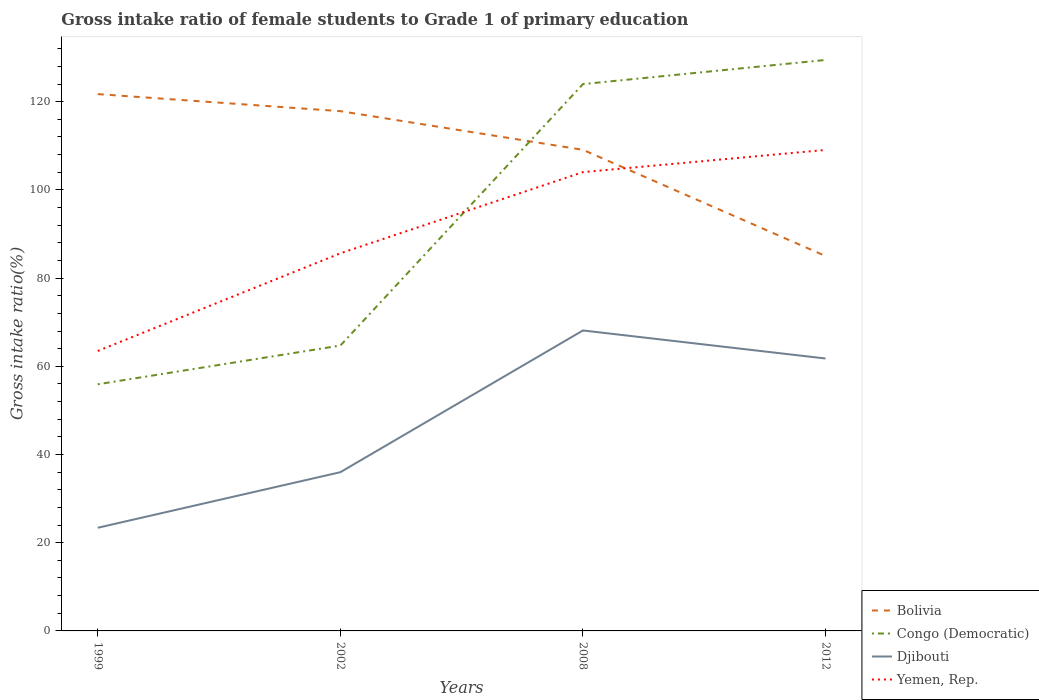How many different coloured lines are there?
Keep it short and to the point. 4. Does the line corresponding to Yemen, Rep. intersect with the line corresponding to Bolivia?
Your answer should be very brief. Yes. Is the number of lines equal to the number of legend labels?
Offer a terse response. Yes. Across all years, what is the maximum gross intake ratio in Djibouti?
Ensure brevity in your answer.  23.39. What is the total gross intake ratio in Yemen, Rep. in the graph?
Ensure brevity in your answer.  -5.03. What is the difference between the highest and the second highest gross intake ratio in Bolivia?
Give a very brief answer. 36.71. How many years are there in the graph?
Give a very brief answer. 4. What is the difference between two consecutive major ticks on the Y-axis?
Keep it short and to the point. 20. Does the graph contain grids?
Provide a short and direct response. No. Where does the legend appear in the graph?
Your response must be concise. Bottom right. How many legend labels are there?
Your answer should be very brief. 4. What is the title of the graph?
Your response must be concise. Gross intake ratio of female students to Grade 1 of primary education. Does "Greece" appear as one of the legend labels in the graph?
Provide a succinct answer. No. What is the label or title of the Y-axis?
Your answer should be very brief. Gross intake ratio(%). What is the Gross intake ratio(%) of Bolivia in 1999?
Provide a succinct answer. 121.71. What is the Gross intake ratio(%) in Congo (Democratic) in 1999?
Provide a succinct answer. 55.92. What is the Gross intake ratio(%) in Djibouti in 1999?
Your response must be concise. 23.39. What is the Gross intake ratio(%) in Yemen, Rep. in 1999?
Provide a short and direct response. 63.48. What is the Gross intake ratio(%) of Bolivia in 2002?
Your answer should be very brief. 117.84. What is the Gross intake ratio(%) in Congo (Democratic) in 2002?
Keep it short and to the point. 64.7. What is the Gross intake ratio(%) of Djibouti in 2002?
Offer a terse response. 35.99. What is the Gross intake ratio(%) of Yemen, Rep. in 2002?
Your response must be concise. 85.62. What is the Gross intake ratio(%) in Bolivia in 2008?
Offer a very short reply. 109.08. What is the Gross intake ratio(%) of Congo (Democratic) in 2008?
Offer a very short reply. 123.98. What is the Gross intake ratio(%) in Djibouti in 2008?
Offer a very short reply. 68.12. What is the Gross intake ratio(%) in Yemen, Rep. in 2008?
Make the answer very short. 104.02. What is the Gross intake ratio(%) of Bolivia in 2012?
Make the answer very short. 85. What is the Gross intake ratio(%) of Congo (Democratic) in 2012?
Give a very brief answer. 129.45. What is the Gross intake ratio(%) of Djibouti in 2012?
Your response must be concise. 61.76. What is the Gross intake ratio(%) of Yemen, Rep. in 2012?
Ensure brevity in your answer.  109.05. Across all years, what is the maximum Gross intake ratio(%) of Bolivia?
Your answer should be very brief. 121.71. Across all years, what is the maximum Gross intake ratio(%) in Congo (Democratic)?
Your answer should be very brief. 129.45. Across all years, what is the maximum Gross intake ratio(%) of Djibouti?
Keep it short and to the point. 68.12. Across all years, what is the maximum Gross intake ratio(%) of Yemen, Rep.?
Offer a very short reply. 109.05. Across all years, what is the minimum Gross intake ratio(%) of Bolivia?
Make the answer very short. 85. Across all years, what is the minimum Gross intake ratio(%) of Congo (Democratic)?
Your answer should be compact. 55.92. Across all years, what is the minimum Gross intake ratio(%) in Djibouti?
Give a very brief answer. 23.39. Across all years, what is the minimum Gross intake ratio(%) in Yemen, Rep.?
Make the answer very short. 63.48. What is the total Gross intake ratio(%) of Bolivia in the graph?
Keep it short and to the point. 433.64. What is the total Gross intake ratio(%) in Congo (Democratic) in the graph?
Provide a succinct answer. 374.06. What is the total Gross intake ratio(%) of Djibouti in the graph?
Make the answer very short. 189.27. What is the total Gross intake ratio(%) of Yemen, Rep. in the graph?
Your answer should be compact. 362.18. What is the difference between the Gross intake ratio(%) of Bolivia in 1999 and that in 2002?
Make the answer very short. 3.87. What is the difference between the Gross intake ratio(%) in Congo (Democratic) in 1999 and that in 2002?
Your answer should be compact. -8.78. What is the difference between the Gross intake ratio(%) in Djibouti in 1999 and that in 2002?
Offer a terse response. -12.6. What is the difference between the Gross intake ratio(%) in Yemen, Rep. in 1999 and that in 2002?
Make the answer very short. -22.14. What is the difference between the Gross intake ratio(%) in Bolivia in 1999 and that in 2008?
Give a very brief answer. 12.63. What is the difference between the Gross intake ratio(%) of Congo (Democratic) in 1999 and that in 2008?
Offer a terse response. -68.06. What is the difference between the Gross intake ratio(%) of Djibouti in 1999 and that in 2008?
Your response must be concise. -44.73. What is the difference between the Gross intake ratio(%) of Yemen, Rep. in 1999 and that in 2008?
Provide a succinct answer. -40.54. What is the difference between the Gross intake ratio(%) in Bolivia in 1999 and that in 2012?
Your answer should be compact. 36.71. What is the difference between the Gross intake ratio(%) in Congo (Democratic) in 1999 and that in 2012?
Your response must be concise. -73.53. What is the difference between the Gross intake ratio(%) of Djibouti in 1999 and that in 2012?
Provide a short and direct response. -38.37. What is the difference between the Gross intake ratio(%) in Yemen, Rep. in 1999 and that in 2012?
Your response must be concise. -45.57. What is the difference between the Gross intake ratio(%) of Bolivia in 2002 and that in 2008?
Provide a short and direct response. 8.76. What is the difference between the Gross intake ratio(%) of Congo (Democratic) in 2002 and that in 2008?
Offer a very short reply. -59.28. What is the difference between the Gross intake ratio(%) in Djibouti in 2002 and that in 2008?
Provide a short and direct response. -32.13. What is the difference between the Gross intake ratio(%) of Yemen, Rep. in 2002 and that in 2008?
Keep it short and to the point. -18.4. What is the difference between the Gross intake ratio(%) in Bolivia in 2002 and that in 2012?
Your answer should be very brief. 32.84. What is the difference between the Gross intake ratio(%) in Congo (Democratic) in 2002 and that in 2012?
Give a very brief answer. -64.75. What is the difference between the Gross intake ratio(%) of Djibouti in 2002 and that in 2012?
Ensure brevity in your answer.  -25.77. What is the difference between the Gross intake ratio(%) of Yemen, Rep. in 2002 and that in 2012?
Provide a short and direct response. -23.44. What is the difference between the Gross intake ratio(%) in Bolivia in 2008 and that in 2012?
Provide a succinct answer. 24.08. What is the difference between the Gross intake ratio(%) in Congo (Democratic) in 2008 and that in 2012?
Your response must be concise. -5.47. What is the difference between the Gross intake ratio(%) of Djibouti in 2008 and that in 2012?
Provide a short and direct response. 6.36. What is the difference between the Gross intake ratio(%) in Yemen, Rep. in 2008 and that in 2012?
Make the answer very short. -5.03. What is the difference between the Gross intake ratio(%) in Bolivia in 1999 and the Gross intake ratio(%) in Congo (Democratic) in 2002?
Your answer should be very brief. 57.01. What is the difference between the Gross intake ratio(%) of Bolivia in 1999 and the Gross intake ratio(%) of Djibouti in 2002?
Your response must be concise. 85.72. What is the difference between the Gross intake ratio(%) of Bolivia in 1999 and the Gross intake ratio(%) of Yemen, Rep. in 2002?
Your answer should be compact. 36.09. What is the difference between the Gross intake ratio(%) in Congo (Democratic) in 1999 and the Gross intake ratio(%) in Djibouti in 2002?
Your response must be concise. 19.93. What is the difference between the Gross intake ratio(%) of Congo (Democratic) in 1999 and the Gross intake ratio(%) of Yemen, Rep. in 2002?
Give a very brief answer. -29.7. What is the difference between the Gross intake ratio(%) in Djibouti in 1999 and the Gross intake ratio(%) in Yemen, Rep. in 2002?
Your answer should be compact. -62.23. What is the difference between the Gross intake ratio(%) of Bolivia in 1999 and the Gross intake ratio(%) of Congo (Democratic) in 2008?
Your answer should be compact. -2.27. What is the difference between the Gross intake ratio(%) in Bolivia in 1999 and the Gross intake ratio(%) in Djibouti in 2008?
Keep it short and to the point. 53.59. What is the difference between the Gross intake ratio(%) in Bolivia in 1999 and the Gross intake ratio(%) in Yemen, Rep. in 2008?
Keep it short and to the point. 17.69. What is the difference between the Gross intake ratio(%) in Congo (Democratic) in 1999 and the Gross intake ratio(%) in Djibouti in 2008?
Offer a very short reply. -12.2. What is the difference between the Gross intake ratio(%) in Congo (Democratic) in 1999 and the Gross intake ratio(%) in Yemen, Rep. in 2008?
Ensure brevity in your answer.  -48.1. What is the difference between the Gross intake ratio(%) in Djibouti in 1999 and the Gross intake ratio(%) in Yemen, Rep. in 2008?
Make the answer very short. -80.63. What is the difference between the Gross intake ratio(%) of Bolivia in 1999 and the Gross intake ratio(%) of Congo (Democratic) in 2012?
Your response must be concise. -7.74. What is the difference between the Gross intake ratio(%) of Bolivia in 1999 and the Gross intake ratio(%) of Djibouti in 2012?
Provide a short and direct response. 59.95. What is the difference between the Gross intake ratio(%) of Bolivia in 1999 and the Gross intake ratio(%) of Yemen, Rep. in 2012?
Your answer should be very brief. 12.66. What is the difference between the Gross intake ratio(%) in Congo (Democratic) in 1999 and the Gross intake ratio(%) in Djibouti in 2012?
Make the answer very short. -5.84. What is the difference between the Gross intake ratio(%) in Congo (Democratic) in 1999 and the Gross intake ratio(%) in Yemen, Rep. in 2012?
Keep it short and to the point. -53.13. What is the difference between the Gross intake ratio(%) of Djibouti in 1999 and the Gross intake ratio(%) of Yemen, Rep. in 2012?
Provide a short and direct response. -85.66. What is the difference between the Gross intake ratio(%) of Bolivia in 2002 and the Gross intake ratio(%) of Congo (Democratic) in 2008?
Your answer should be very brief. -6.14. What is the difference between the Gross intake ratio(%) in Bolivia in 2002 and the Gross intake ratio(%) in Djibouti in 2008?
Provide a short and direct response. 49.72. What is the difference between the Gross intake ratio(%) in Bolivia in 2002 and the Gross intake ratio(%) in Yemen, Rep. in 2008?
Offer a terse response. 13.82. What is the difference between the Gross intake ratio(%) of Congo (Democratic) in 2002 and the Gross intake ratio(%) of Djibouti in 2008?
Offer a terse response. -3.42. What is the difference between the Gross intake ratio(%) in Congo (Democratic) in 2002 and the Gross intake ratio(%) in Yemen, Rep. in 2008?
Provide a short and direct response. -39.32. What is the difference between the Gross intake ratio(%) in Djibouti in 2002 and the Gross intake ratio(%) in Yemen, Rep. in 2008?
Offer a terse response. -68.03. What is the difference between the Gross intake ratio(%) of Bolivia in 2002 and the Gross intake ratio(%) of Congo (Democratic) in 2012?
Provide a succinct answer. -11.61. What is the difference between the Gross intake ratio(%) of Bolivia in 2002 and the Gross intake ratio(%) of Djibouti in 2012?
Provide a short and direct response. 56.08. What is the difference between the Gross intake ratio(%) in Bolivia in 2002 and the Gross intake ratio(%) in Yemen, Rep. in 2012?
Offer a terse response. 8.79. What is the difference between the Gross intake ratio(%) in Congo (Democratic) in 2002 and the Gross intake ratio(%) in Djibouti in 2012?
Keep it short and to the point. 2.94. What is the difference between the Gross intake ratio(%) of Congo (Democratic) in 2002 and the Gross intake ratio(%) of Yemen, Rep. in 2012?
Your answer should be very brief. -44.35. What is the difference between the Gross intake ratio(%) in Djibouti in 2002 and the Gross intake ratio(%) in Yemen, Rep. in 2012?
Give a very brief answer. -73.06. What is the difference between the Gross intake ratio(%) of Bolivia in 2008 and the Gross intake ratio(%) of Congo (Democratic) in 2012?
Give a very brief answer. -20.37. What is the difference between the Gross intake ratio(%) in Bolivia in 2008 and the Gross intake ratio(%) in Djibouti in 2012?
Your answer should be very brief. 47.32. What is the difference between the Gross intake ratio(%) in Bolivia in 2008 and the Gross intake ratio(%) in Yemen, Rep. in 2012?
Your answer should be very brief. 0.03. What is the difference between the Gross intake ratio(%) of Congo (Democratic) in 2008 and the Gross intake ratio(%) of Djibouti in 2012?
Your answer should be compact. 62.22. What is the difference between the Gross intake ratio(%) in Congo (Democratic) in 2008 and the Gross intake ratio(%) in Yemen, Rep. in 2012?
Your response must be concise. 14.93. What is the difference between the Gross intake ratio(%) of Djibouti in 2008 and the Gross intake ratio(%) of Yemen, Rep. in 2012?
Provide a succinct answer. -40.93. What is the average Gross intake ratio(%) of Bolivia per year?
Ensure brevity in your answer.  108.41. What is the average Gross intake ratio(%) of Congo (Democratic) per year?
Give a very brief answer. 93.51. What is the average Gross intake ratio(%) of Djibouti per year?
Offer a very short reply. 47.32. What is the average Gross intake ratio(%) of Yemen, Rep. per year?
Offer a very short reply. 90.54. In the year 1999, what is the difference between the Gross intake ratio(%) of Bolivia and Gross intake ratio(%) of Congo (Democratic)?
Make the answer very short. 65.79. In the year 1999, what is the difference between the Gross intake ratio(%) in Bolivia and Gross intake ratio(%) in Djibouti?
Your answer should be compact. 98.32. In the year 1999, what is the difference between the Gross intake ratio(%) of Bolivia and Gross intake ratio(%) of Yemen, Rep.?
Make the answer very short. 58.23. In the year 1999, what is the difference between the Gross intake ratio(%) of Congo (Democratic) and Gross intake ratio(%) of Djibouti?
Ensure brevity in your answer.  32.53. In the year 1999, what is the difference between the Gross intake ratio(%) in Congo (Democratic) and Gross intake ratio(%) in Yemen, Rep.?
Give a very brief answer. -7.56. In the year 1999, what is the difference between the Gross intake ratio(%) in Djibouti and Gross intake ratio(%) in Yemen, Rep.?
Keep it short and to the point. -40.09. In the year 2002, what is the difference between the Gross intake ratio(%) in Bolivia and Gross intake ratio(%) in Congo (Democratic)?
Ensure brevity in your answer.  53.14. In the year 2002, what is the difference between the Gross intake ratio(%) of Bolivia and Gross intake ratio(%) of Djibouti?
Offer a terse response. 81.85. In the year 2002, what is the difference between the Gross intake ratio(%) of Bolivia and Gross intake ratio(%) of Yemen, Rep.?
Keep it short and to the point. 32.22. In the year 2002, what is the difference between the Gross intake ratio(%) in Congo (Democratic) and Gross intake ratio(%) in Djibouti?
Make the answer very short. 28.71. In the year 2002, what is the difference between the Gross intake ratio(%) in Congo (Democratic) and Gross intake ratio(%) in Yemen, Rep.?
Provide a short and direct response. -20.92. In the year 2002, what is the difference between the Gross intake ratio(%) in Djibouti and Gross intake ratio(%) in Yemen, Rep.?
Provide a short and direct response. -49.63. In the year 2008, what is the difference between the Gross intake ratio(%) of Bolivia and Gross intake ratio(%) of Congo (Democratic)?
Your answer should be very brief. -14.9. In the year 2008, what is the difference between the Gross intake ratio(%) of Bolivia and Gross intake ratio(%) of Djibouti?
Provide a short and direct response. 40.96. In the year 2008, what is the difference between the Gross intake ratio(%) of Bolivia and Gross intake ratio(%) of Yemen, Rep.?
Make the answer very short. 5.06. In the year 2008, what is the difference between the Gross intake ratio(%) of Congo (Democratic) and Gross intake ratio(%) of Djibouti?
Ensure brevity in your answer.  55.86. In the year 2008, what is the difference between the Gross intake ratio(%) of Congo (Democratic) and Gross intake ratio(%) of Yemen, Rep.?
Your response must be concise. 19.96. In the year 2008, what is the difference between the Gross intake ratio(%) in Djibouti and Gross intake ratio(%) in Yemen, Rep.?
Your answer should be compact. -35.9. In the year 2012, what is the difference between the Gross intake ratio(%) in Bolivia and Gross intake ratio(%) in Congo (Democratic)?
Provide a succinct answer. -44.45. In the year 2012, what is the difference between the Gross intake ratio(%) in Bolivia and Gross intake ratio(%) in Djibouti?
Offer a terse response. 23.24. In the year 2012, what is the difference between the Gross intake ratio(%) in Bolivia and Gross intake ratio(%) in Yemen, Rep.?
Give a very brief answer. -24.05. In the year 2012, what is the difference between the Gross intake ratio(%) in Congo (Democratic) and Gross intake ratio(%) in Djibouti?
Make the answer very short. 67.69. In the year 2012, what is the difference between the Gross intake ratio(%) of Congo (Democratic) and Gross intake ratio(%) of Yemen, Rep.?
Provide a short and direct response. 20.4. In the year 2012, what is the difference between the Gross intake ratio(%) of Djibouti and Gross intake ratio(%) of Yemen, Rep.?
Ensure brevity in your answer.  -47.29. What is the ratio of the Gross intake ratio(%) of Bolivia in 1999 to that in 2002?
Offer a very short reply. 1.03. What is the ratio of the Gross intake ratio(%) in Congo (Democratic) in 1999 to that in 2002?
Provide a succinct answer. 0.86. What is the ratio of the Gross intake ratio(%) in Djibouti in 1999 to that in 2002?
Keep it short and to the point. 0.65. What is the ratio of the Gross intake ratio(%) in Yemen, Rep. in 1999 to that in 2002?
Offer a very short reply. 0.74. What is the ratio of the Gross intake ratio(%) of Bolivia in 1999 to that in 2008?
Keep it short and to the point. 1.12. What is the ratio of the Gross intake ratio(%) of Congo (Democratic) in 1999 to that in 2008?
Keep it short and to the point. 0.45. What is the ratio of the Gross intake ratio(%) of Djibouti in 1999 to that in 2008?
Give a very brief answer. 0.34. What is the ratio of the Gross intake ratio(%) in Yemen, Rep. in 1999 to that in 2008?
Provide a succinct answer. 0.61. What is the ratio of the Gross intake ratio(%) of Bolivia in 1999 to that in 2012?
Your answer should be very brief. 1.43. What is the ratio of the Gross intake ratio(%) of Congo (Democratic) in 1999 to that in 2012?
Your answer should be compact. 0.43. What is the ratio of the Gross intake ratio(%) in Djibouti in 1999 to that in 2012?
Keep it short and to the point. 0.38. What is the ratio of the Gross intake ratio(%) of Yemen, Rep. in 1999 to that in 2012?
Your response must be concise. 0.58. What is the ratio of the Gross intake ratio(%) of Bolivia in 2002 to that in 2008?
Your answer should be compact. 1.08. What is the ratio of the Gross intake ratio(%) in Congo (Democratic) in 2002 to that in 2008?
Your response must be concise. 0.52. What is the ratio of the Gross intake ratio(%) in Djibouti in 2002 to that in 2008?
Make the answer very short. 0.53. What is the ratio of the Gross intake ratio(%) of Yemen, Rep. in 2002 to that in 2008?
Make the answer very short. 0.82. What is the ratio of the Gross intake ratio(%) in Bolivia in 2002 to that in 2012?
Your answer should be compact. 1.39. What is the ratio of the Gross intake ratio(%) in Congo (Democratic) in 2002 to that in 2012?
Keep it short and to the point. 0.5. What is the ratio of the Gross intake ratio(%) in Djibouti in 2002 to that in 2012?
Your answer should be very brief. 0.58. What is the ratio of the Gross intake ratio(%) in Yemen, Rep. in 2002 to that in 2012?
Make the answer very short. 0.79. What is the ratio of the Gross intake ratio(%) of Bolivia in 2008 to that in 2012?
Provide a succinct answer. 1.28. What is the ratio of the Gross intake ratio(%) of Congo (Democratic) in 2008 to that in 2012?
Provide a succinct answer. 0.96. What is the ratio of the Gross intake ratio(%) of Djibouti in 2008 to that in 2012?
Make the answer very short. 1.1. What is the ratio of the Gross intake ratio(%) of Yemen, Rep. in 2008 to that in 2012?
Keep it short and to the point. 0.95. What is the difference between the highest and the second highest Gross intake ratio(%) of Bolivia?
Provide a short and direct response. 3.87. What is the difference between the highest and the second highest Gross intake ratio(%) of Congo (Democratic)?
Provide a short and direct response. 5.47. What is the difference between the highest and the second highest Gross intake ratio(%) of Djibouti?
Provide a succinct answer. 6.36. What is the difference between the highest and the second highest Gross intake ratio(%) of Yemen, Rep.?
Ensure brevity in your answer.  5.03. What is the difference between the highest and the lowest Gross intake ratio(%) of Bolivia?
Offer a very short reply. 36.71. What is the difference between the highest and the lowest Gross intake ratio(%) in Congo (Democratic)?
Your answer should be compact. 73.53. What is the difference between the highest and the lowest Gross intake ratio(%) in Djibouti?
Offer a very short reply. 44.73. What is the difference between the highest and the lowest Gross intake ratio(%) in Yemen, Rep.?
Your answer should be compact. 45.57. 